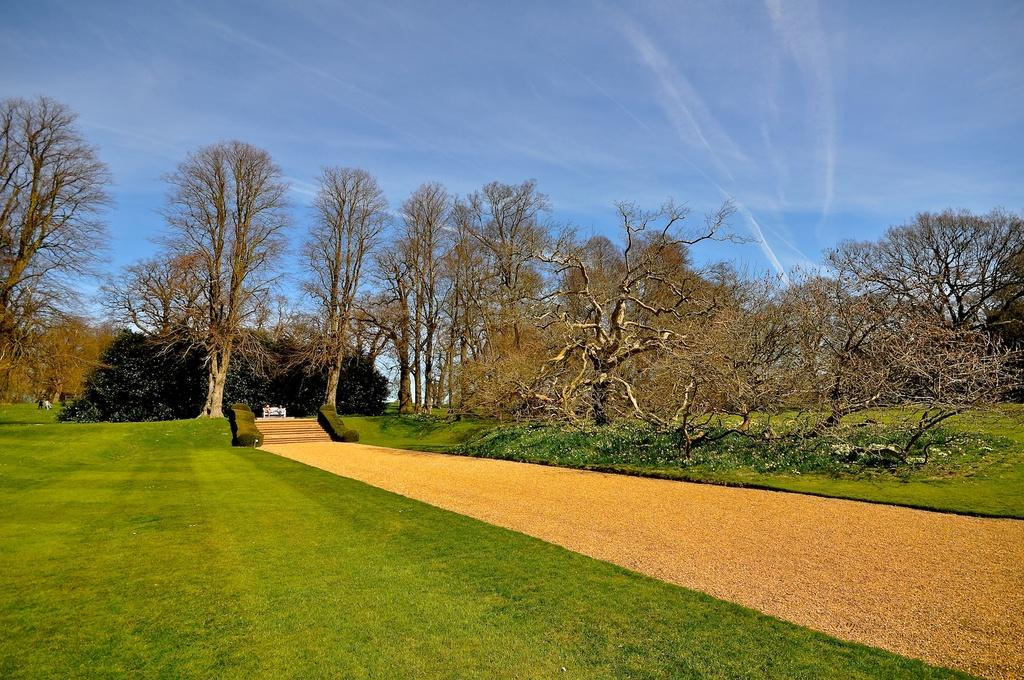What type of vegetation is present in the image? There are trees in the image. What type of ground cover is present in the image? There is grass in the image. What architectural feature can be seen in the image? There are steps in the image. What type of surface is visible for walking or traveling in the image? There is: There is a path in the image. What can be seen in the background of the image? The sky is visible in the background of the image. What type of curtain is hanging in the trees in the image? There is no curtain present in the image; it features trees, grass, steps, a path, and the sky. 